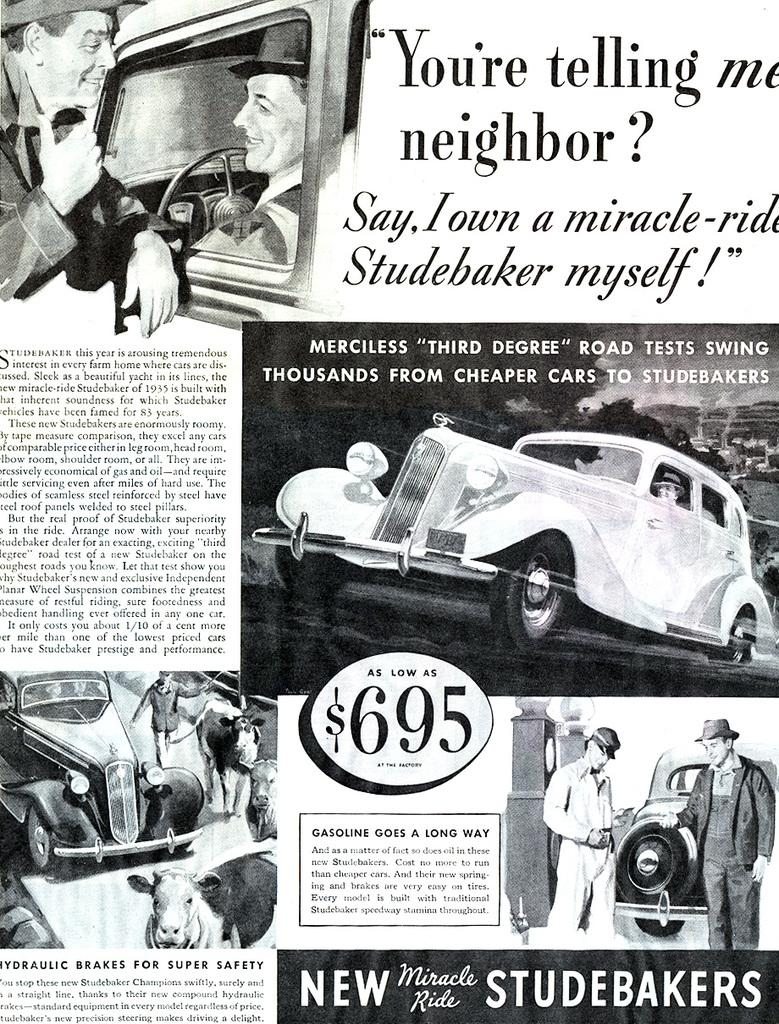What is featured on the poster in the image? The poster contains text and depicts vehicles. What types of vehicles are shown on the poster? The specific types of vehicles cannot be determined from the provided facts. Are there any people in the poster? Yes, there are people standing and sitting in the poster. What type of lock is used to secure the sheet in the image? There is no lock or sheet present in the image; it features a poster with text and vehicles, as well as people standing and sitting. 